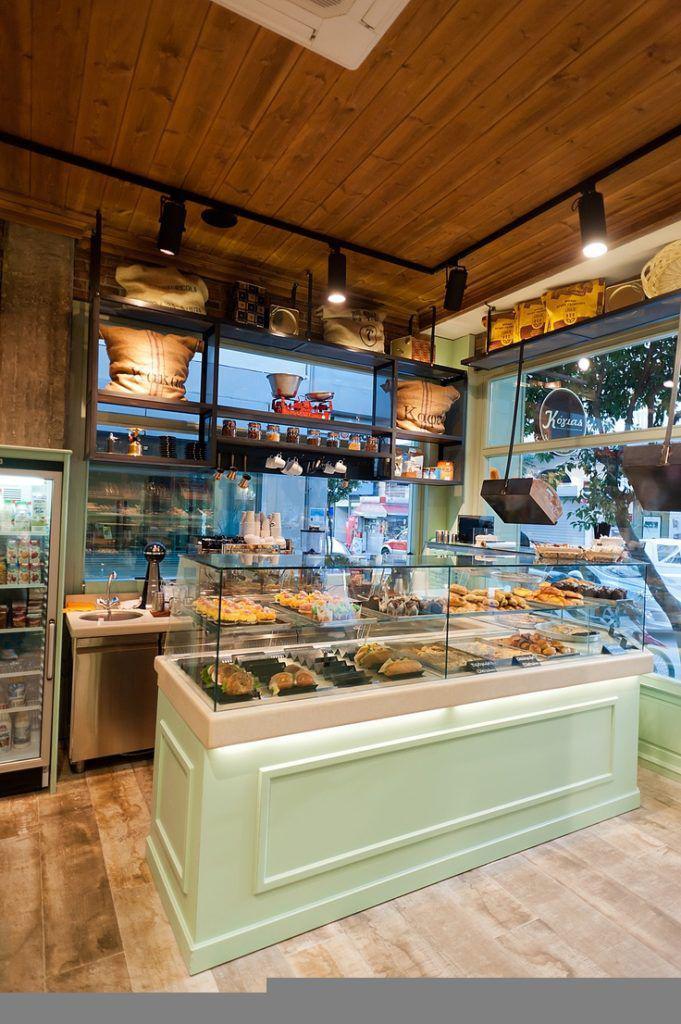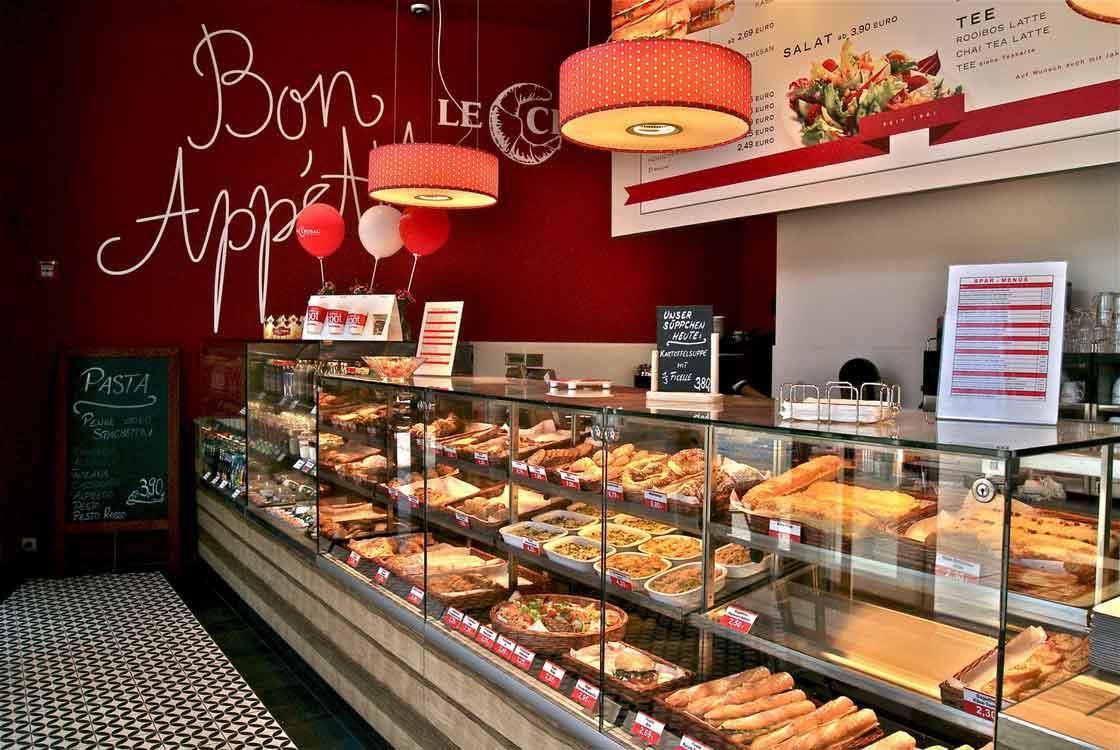The first image is the image on the left, the second image is the image on the right. For the images shown, is this caption "One bakery has a glassed display that curves around a corner." true? Answer yes or no. No. The first image is the image on the left, the second image is the image on the right. Considering the images on both sides, is "There are red lamps hanging from the ceiling." valid? Answer yes or no. Yes. 